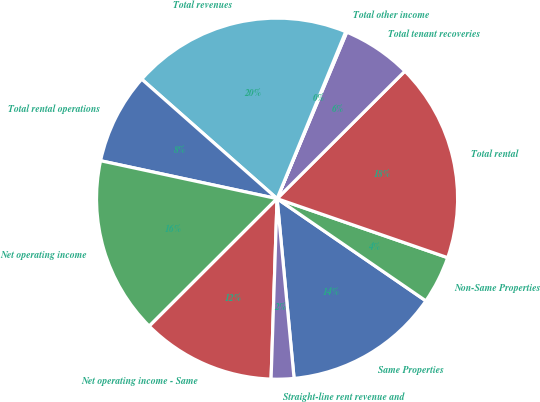Convert chart. <chart><loc_0><loc_0><loc_500><loc_500><pie_chart><fcel>Same Properties<fcel>Non-Same Properties<fcel>Total rental<fcel>Total tenant recoveries<fcel>Total other income<fcel>Total revenues<fcel>Total rental operations<fcel>Net operating income<fcel>Net operating income - Same<fcel>Straight-line rent revenue and<nl><fcel>13.92%<fcel>4.28%<fcel>17.78%<fcel>6.21%<fcel>0.1%<fcel>19.7%<fcel>8.14%<fcel>15.85%<fcel>11.99%<fcel>2.03%<nl></chart> 